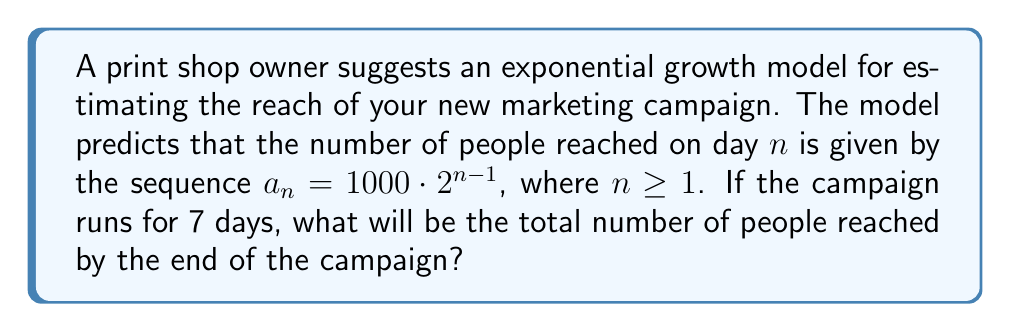Could you help me with this problem? Let's approach this step-by-step:

1) The sequence is given by $a_n = 1000 \cdot 2^{n-1}$ for $n \geq 1$.

2) We need to find the sum of this sequence for the first 7 terms (7 days).

3) Let's calculate each term:

   Day 1: $a_1 = 1000 \cdot 2^{1-1} = 1000 \cdot 1 = 1000$
   Day 2: $a_2 = 1000 \cdot 2^{2-1} = 1000 \cdot 2 = 2000$
   Day 3: $a_3 = 1000 \cdot 2^{3-1} = 1000 \cdot 4 = 4000$
   Day 4: $a_4 = 1000 \cdot 2^{4-1} = 1000 \cdot 8 = 8000$
   Day 5: $a_5 = 1000 \cdot 2^{5-1} = 1000 \cdot 16 = 16000$
   Day 6: $a_6 = 1000 \cdot 2^{6-1} = 1000 \cdot 32 = 32000$
   Day 7: $a_7 = 1000 \cdot 2^{7-1} = 1000 \cdot 64 = 64000$

4) Now, we need to sum these values:

   $S_7 = 1000 + 2000 + 4000 + 8000 + 16000 + 32000 + 64000$

5) We can simplify this sum:

   $S_7 = 1000(1 + 2 + 4 + 8 + 16 + 32 + 64)$

6) The sum in parentheses is a geometric series with first term $a=1$ and common ratio $r=2$. The sum of a geometric series is given by the formula:

   $$S_n = \frac{a(1-r^n)}{1-r}$$ where $n=7$, $a=1$, and $r=2$

7) Applying this formula:

   $$S_7 = 1000 \cdot \frac{1(1-2^7)}{1-2} = 1000 \cdot \frac{1-128}{-1} = 1000 \cdot 127 = 127000$$

Therefore, the total number of people reached by the end of the 7-day campaign is 127,000.
Answer: 127,000 people 